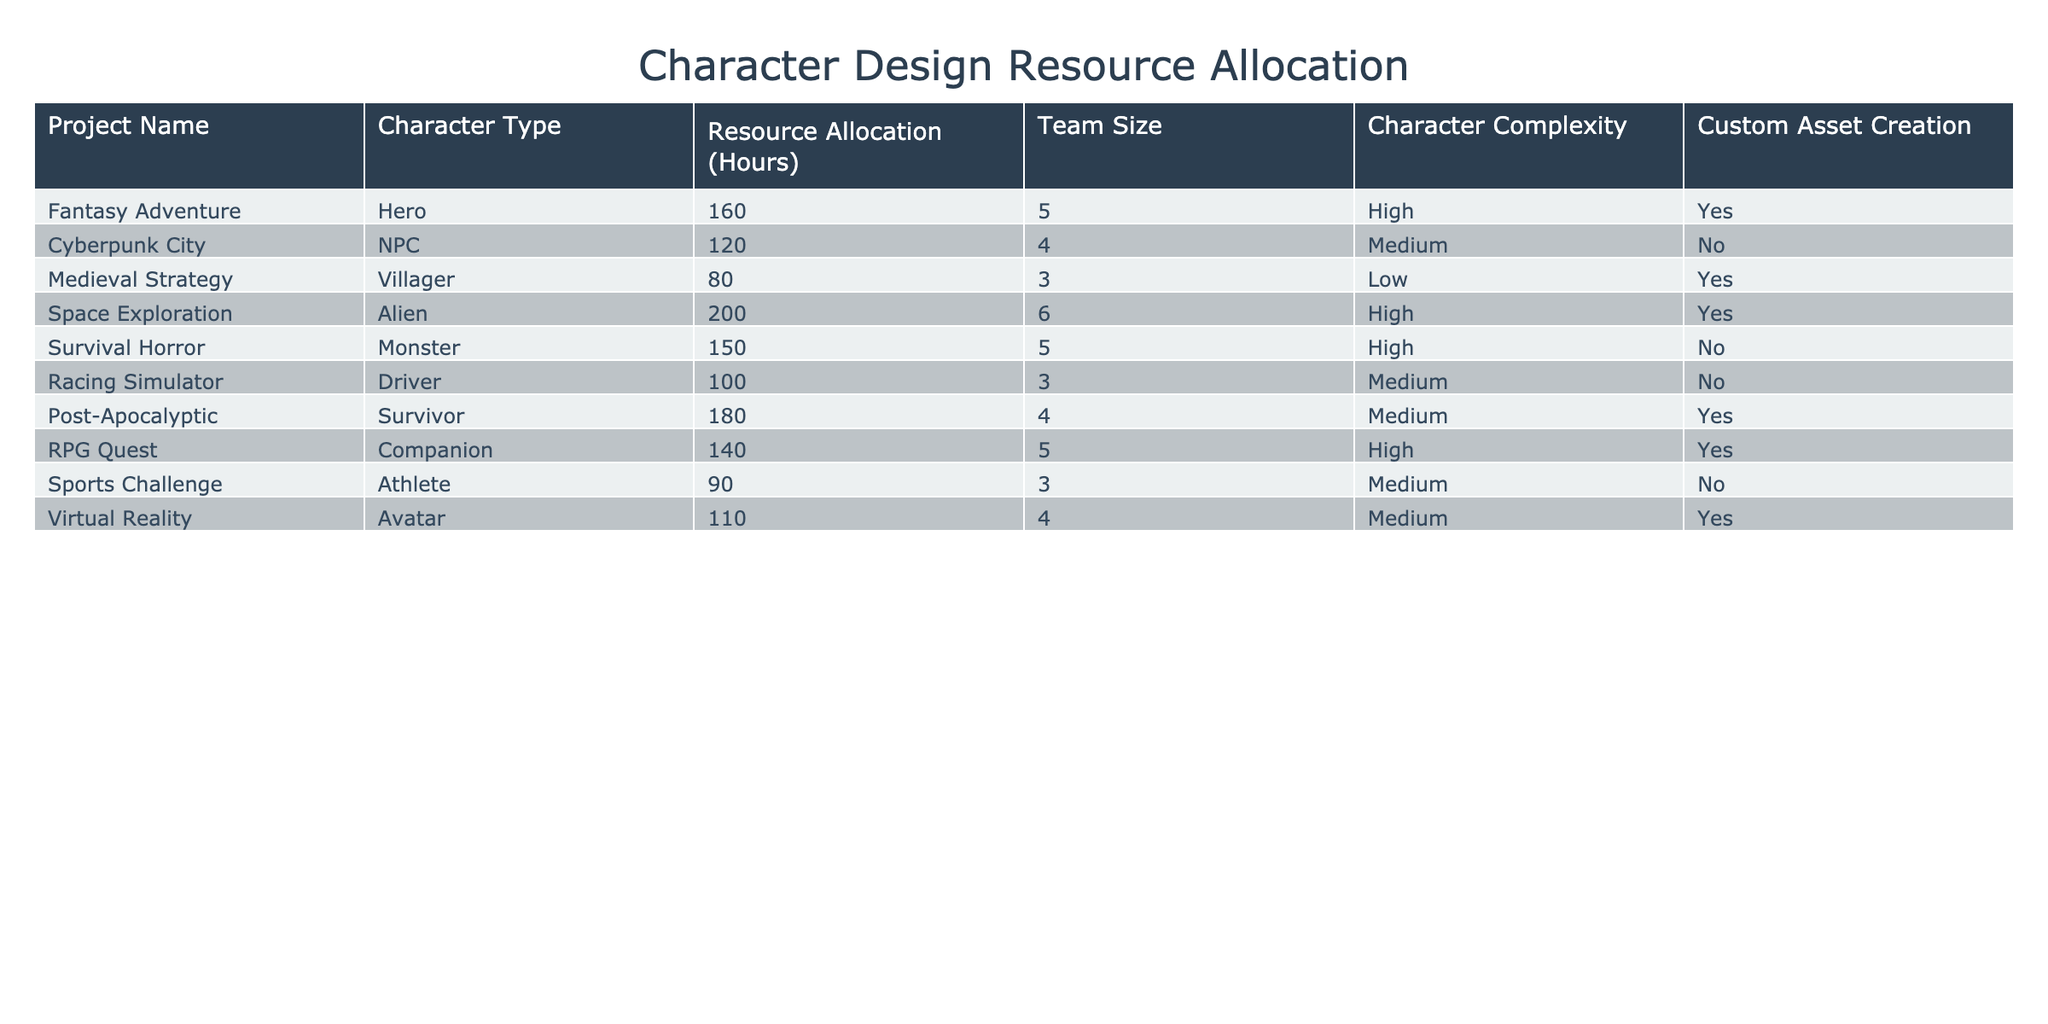What is the total resource allocation for the project "Space Exploration"? The resource allocation for "Space Exploration" is listed as 200 hours. Therefore, the total for this project is simply 200 hours.
Answer: 200 hours Which character type has the highest complexity rating? From the table, both "Hero" (Fantasy Adventure), "Alien" (Space Exploration), "Monster" (Survival Horror), and "Companion" (RPG Quest) have a complexity rating of "High". The highest complexity rating is "High".
Answer: High What is the average resource allocation for characters categorized as "Medium" complexity? The projects with "Medium" complexity are "Cyberpunk City" (120 hours), "Racing Simulator" (100 hours), "Post-Apocalyptic" (180 hours), "Sports Challenge" (90 hours), and "Virtual Reality" (110 hours). We first sum these hours (120 + 100 + 180 + 90 + 110 = 600), which we divide by the number of projects (5) to get the average resource allocation of 600/5 = 120.
Answer: 120 hours Does the project "RPG Quest" involve custom asset creation? Looking at the "Custom Asset Creation" column for "RPG Quest", it is marked "Yes", indicating that custom assets are created for this project.
Answer: Yes What is the total team size for all projects categorized as "High" complexity? The projects with "High" complexity are "Hero" (5 team members), "Alien" (6), "Monster" (5), and "Companion" (5). By adding these together (5 + 6 + 5 + 5 = 21), we find that the total team size for these projects is 21 members.
Answer: 21 members 